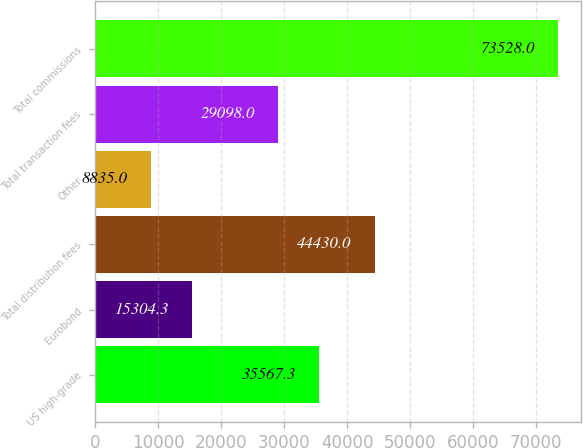<chart> <loc_0><loc_0><loc_500><loc_500><bar_chart><fcel>US high-grade<fcel>Eurobond<fcel>Total distribution fees<fcel>Other<fcel>Total transaction fees<fcel>Total commissions<nl><fcel>35567.3<fcel>15304.3<fcel>44430<fcel>8835<fcel>29098<fcel>73528<nl></chart> 